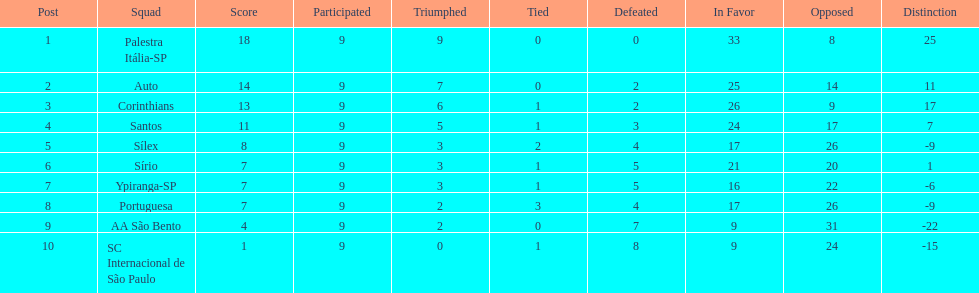Which team was the top scoring team? Palestra Itália-SP. 